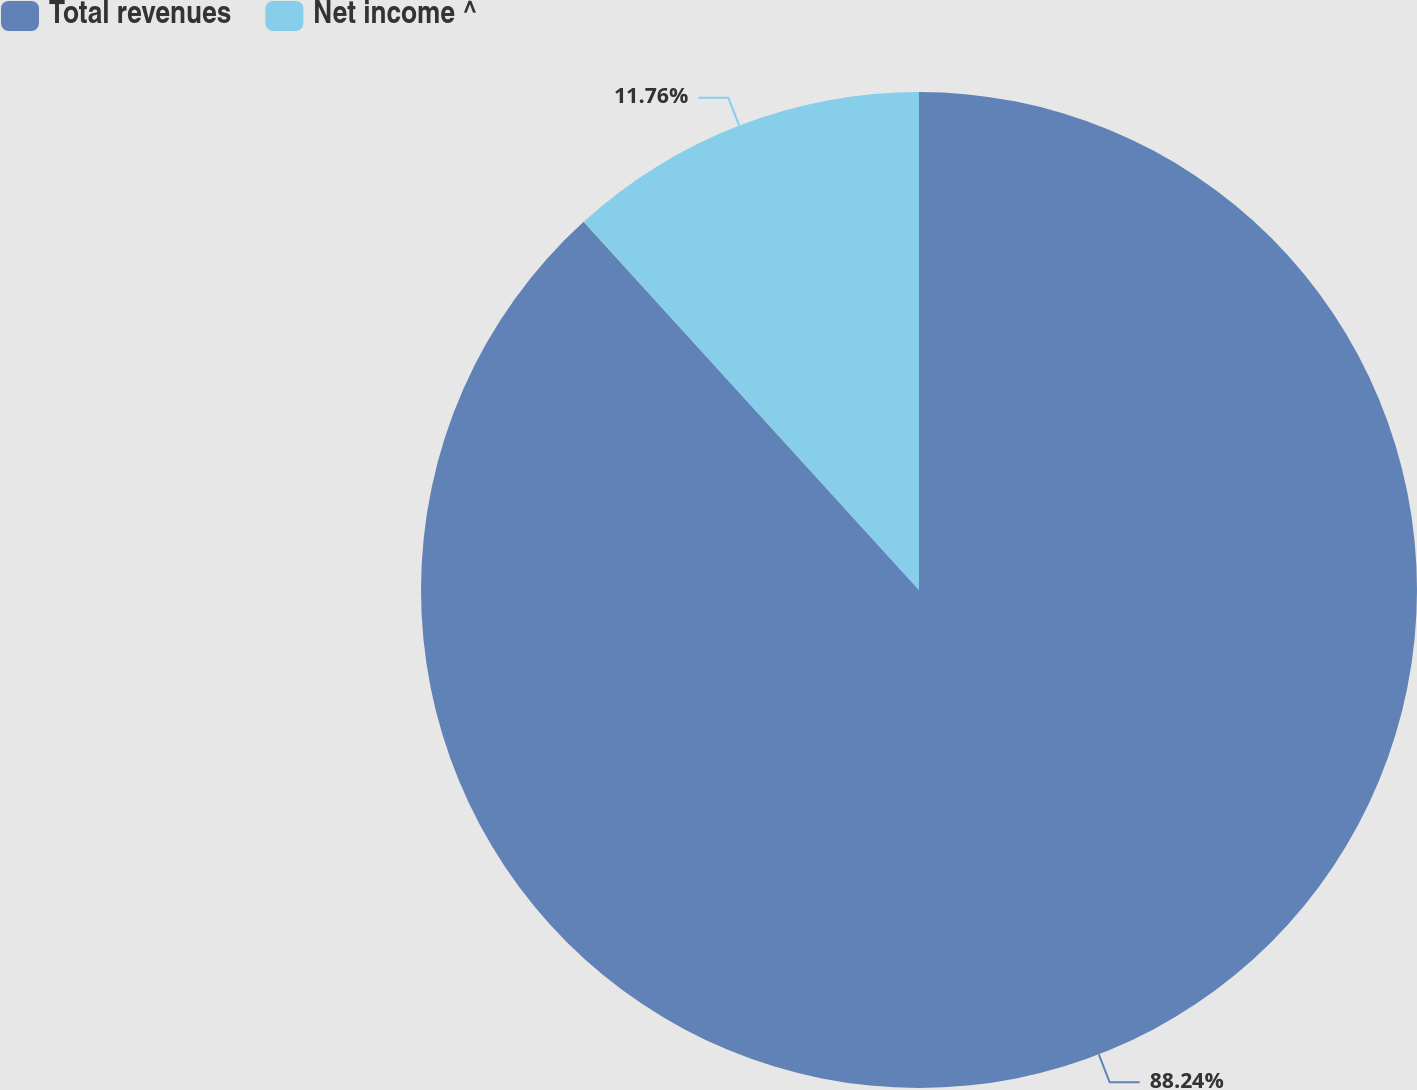<chart> <loc_0><loc_0><loc_500><loc_500><pie_chart><fcel>Total revenues<fcel>Net income ^<nl><fcel>88.24%<fcel>11.76%<nl></chart> 